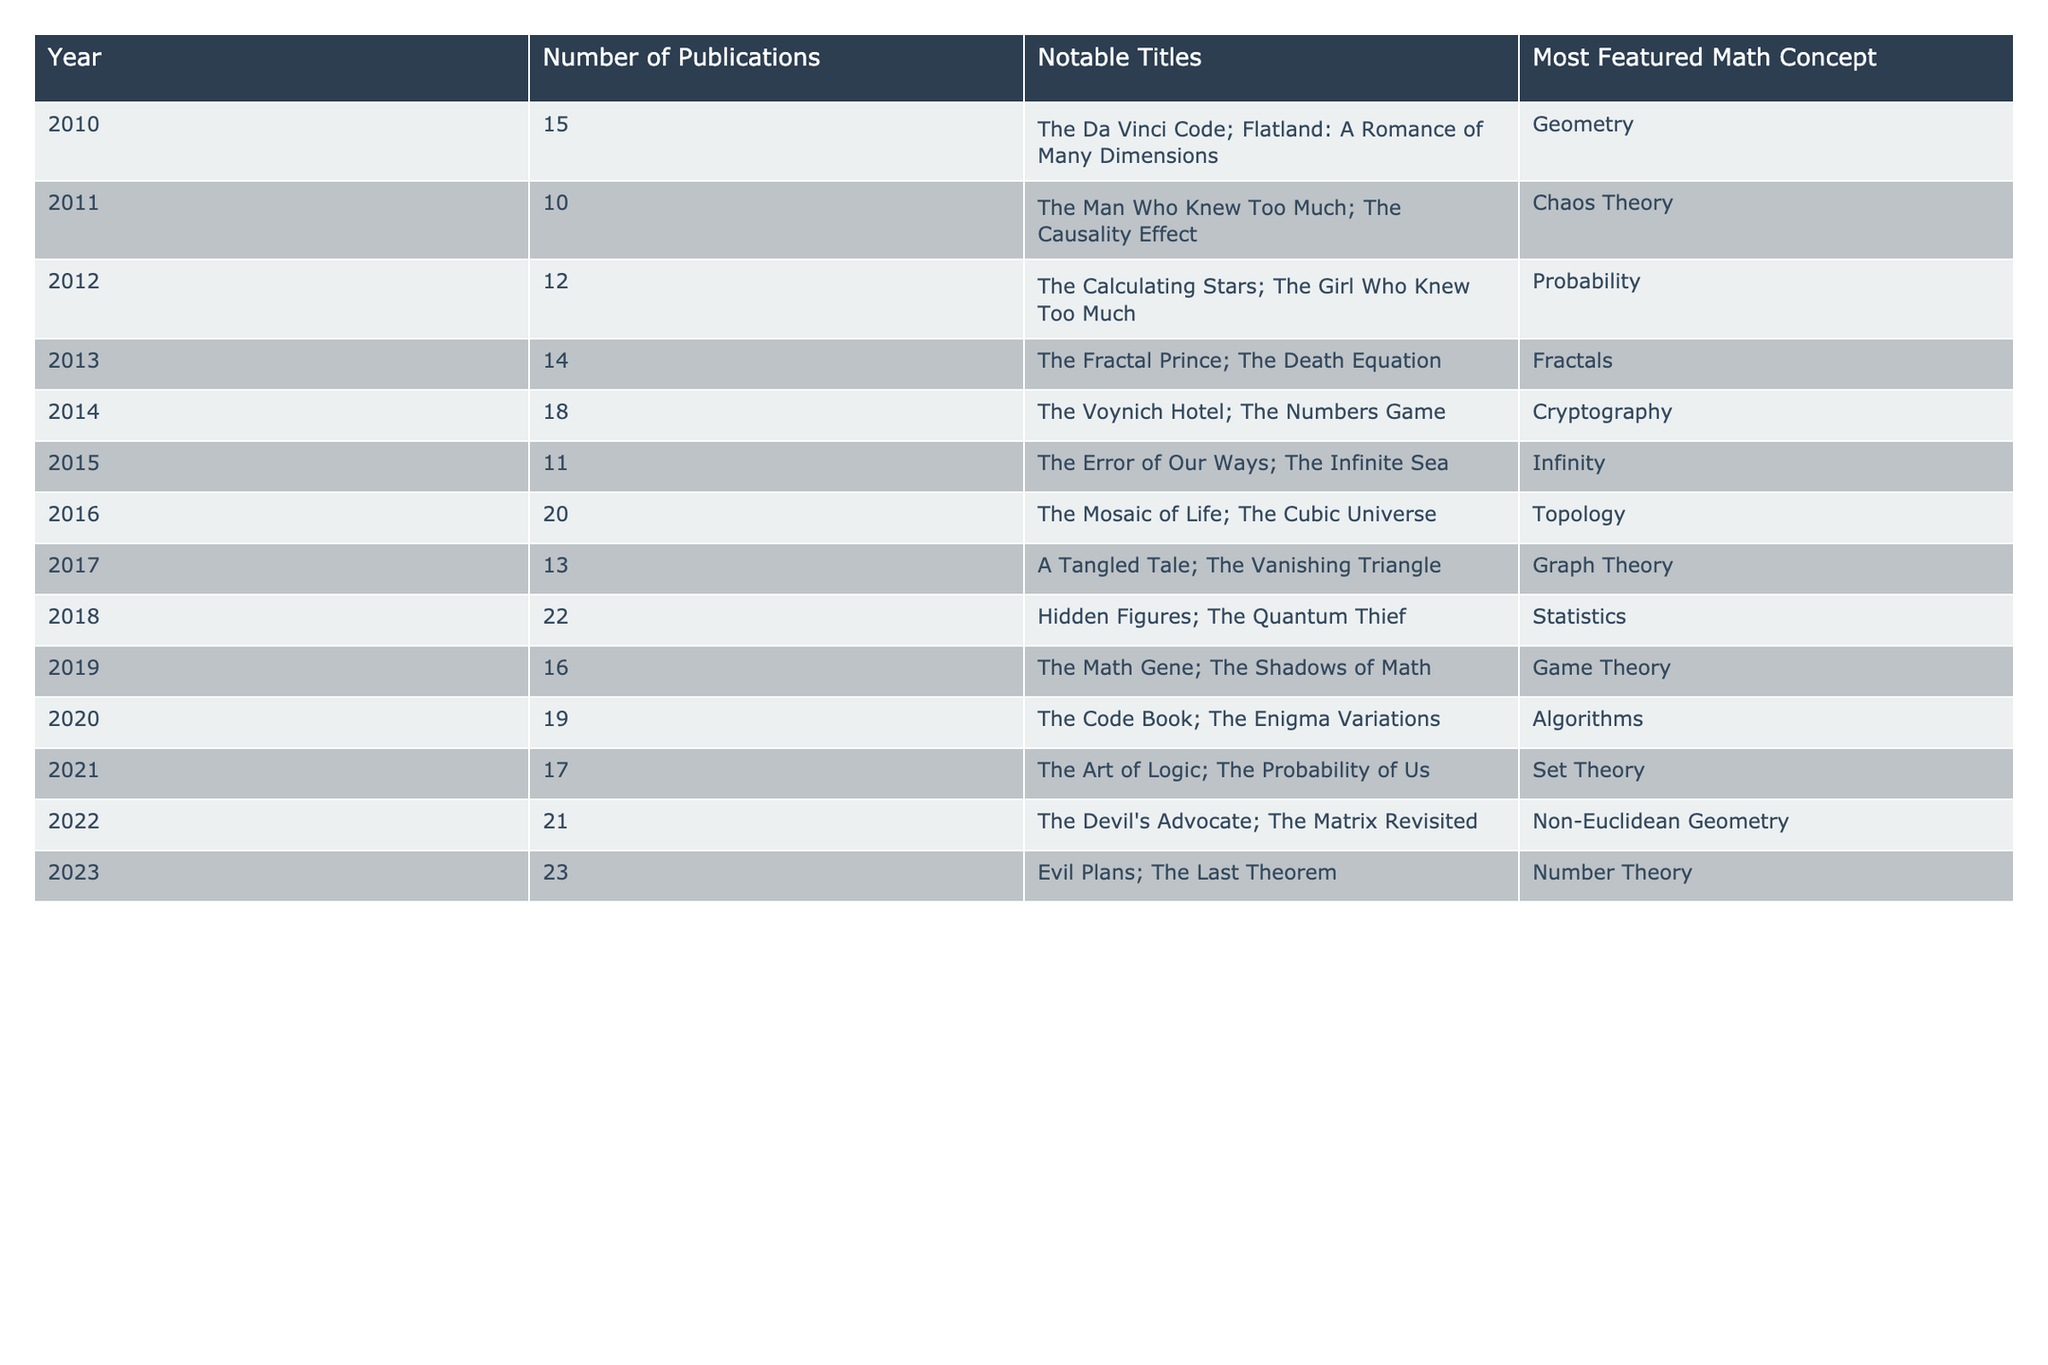What was the year with the highest number of publications? Looking at the "Number of Publications" column, the highest value is 23, which corresponds to the year 2023.
Answer: 2023 How many more publications were there in 2022 compared to 2011? The number of publications in 2022 is 21, and in 2011 it is 10. The difference is 21 - 10 = 11.
Answer: 11 What is the most featured math concept in the years 2014 and 2023? In 2014, the most featured concept is "Cryptography," and in 2023, it is "Number Theory."
Answer: Cryptography and Number Theory What was the average number of publications from 2010 to 2019? The total number of publications from 2010 to 2019 is 15 + 10 + 12 + 14 + 18 + 11 + 20 + 22 + 16 =  14.78, and there are 10 years, so the average is 14.78/10 = 15.57.
Answer: 15.57 Is the number of publications in 2016 greater than in 2010? In 2016, there were 20 publications, and in 2010, there were 15. Since 20 is greater than 15, the statement is true.
Answer: Yes Which year experienced the least number of publications and what was the count? Comparing the "Number of Publications," the least number is 10 in the year 2011.
Answer: 2011, 10 What is the difference in the number of publications between 2015 and 2017? In 2015, there were 11 publications, and in 2017, there were 13. The difference is 13 - 11 = 2.
Answer: 2 Which notable title from 2022 features a math concept related to geometry? The notable title from 2022 is "The Matrix Revisited," which involves "Non-Euclidean Geometry," a geometry concept.
Answer: The Matrix Revisited, Non-Euclidean Geometry How many years had at least 18 publications? From the table, the years with at least 18 publications are 2014 (18), 2016 (20), 2018 (22), 2020 (19), 2022 (21), and 2023 (23), totaling 6 years.
Answer: 6 What is the total number of publications from 2013 to 2021? The total from 2013 to 2021 is 14 + 18 + 11 + 20 + 17 = 80.
Answer: 80 What was the trend in the number of publications from 2010 to 2023? The trend shows an overall increase in the number of publications from 2010 to 2023, rising from 15 in 2010 to 23 in 2023.
Answer: Increasing trend 